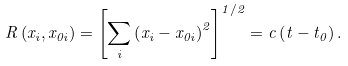Convert formula to latex. <formula><loc_0><loc_0><loc_500><loc_500>R \left ( x _ { i } , x _ { 0 i } \right ) = \left [ \sum _ { i } \left ( x _ { i } - x _ { 0 i } \right ) ^ { 2 } \right ] ^ { 1 / 2 } = c \left ( t - t _ { 0 } \right ) .</formula> 